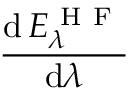Convert formula to latex. <formula><loc_0><loc_0><loc_500><loc_500>\frac { d \, E _ { \lambda } ^ { H F } } { d \lambda }</formula> 